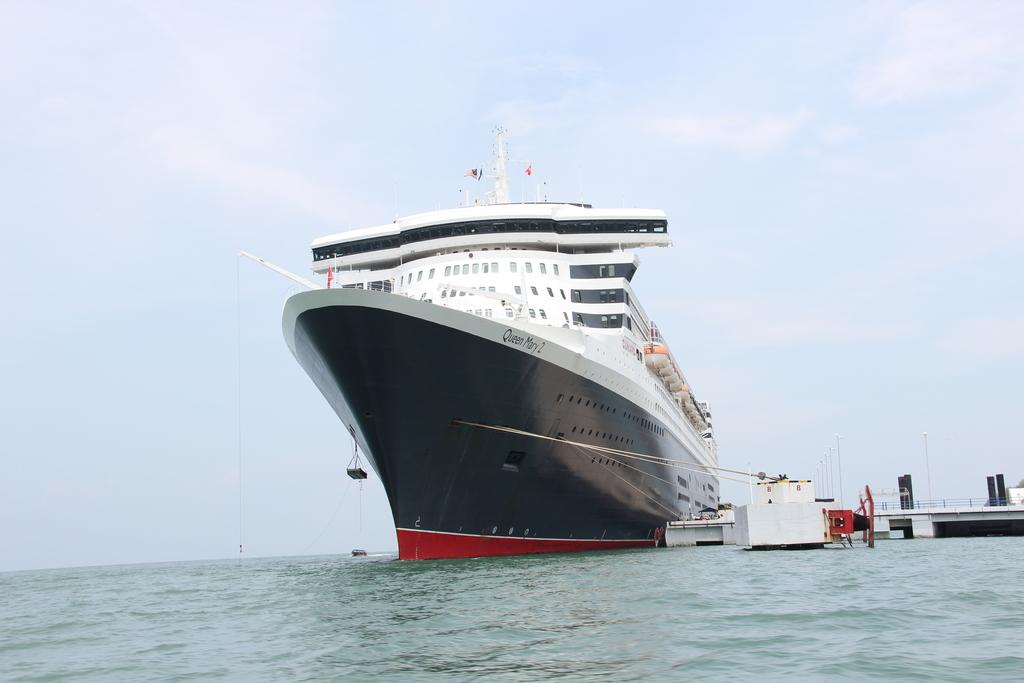What type of vehicle is in the image? There is a ship in the image. Are there any other vehicles in the image? Yes, there are boats in the image. Where are the ship and boats located in relation to the water? The ship and boats are above the water. What structure can be seen in the image? There is a platform in the image. What type of barrier is present in the image? There is a fence in the image. What are the poles used for in the image? The poles are likely used for supporting the flag or other structures. What is attached to one of the poles? There is a flag in the image. What can be seen in the background of the image? The sky is visible in the background of the image, and there are clouds in the sky. What type of mist can be seen surrounding the ship and boats in the image? There is no mist present in the image; the ship and boats are above the water, and the sky is visible in the background. Can you see any stars or planets in the image? No, the image does not depict space; it shows a ship, boats, and other structures on or near the water. 